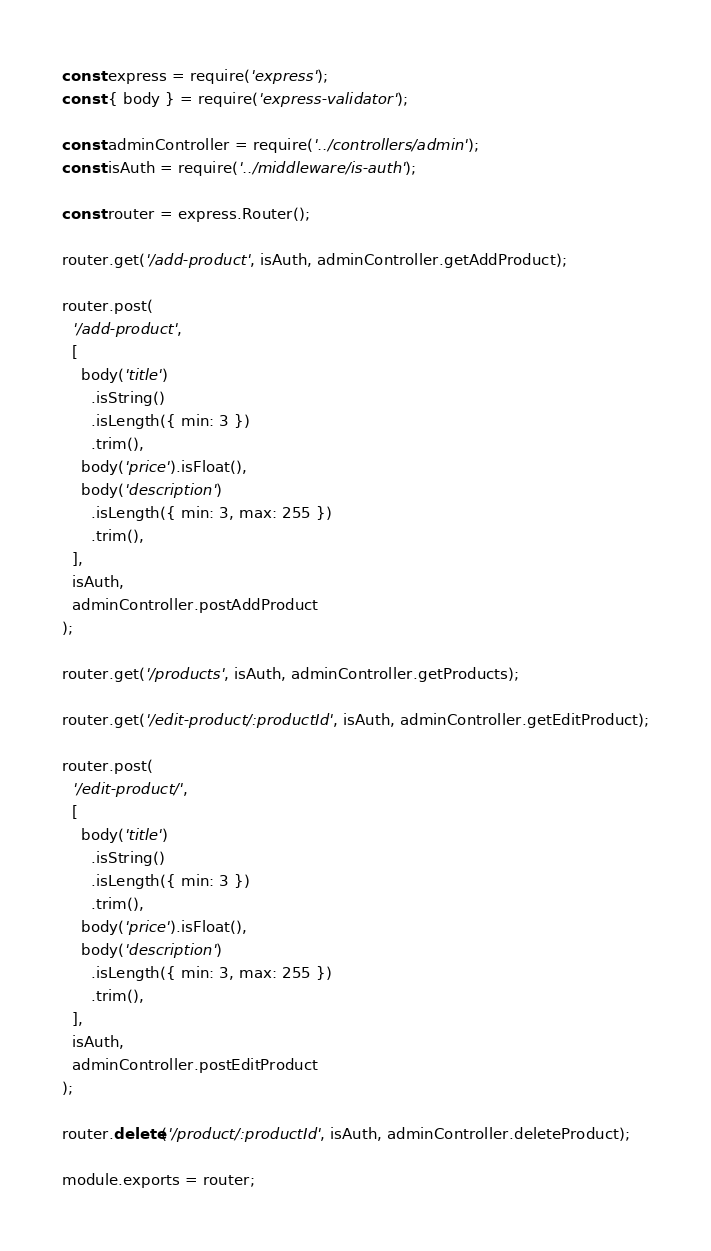Convert code to text. <code><loc_0><loc_0><loc_500><loc_500><_JavaScript_>const express = require('express');
const { body } = require('express-validator');

const adminController = require('../controllers/admin');
const isAuth = require('../middleware/is-auth');

const router = express.Router();

router.get('/add-product', isAuth, adminController.getAddProduct);

router.post(
  '/add-product',
  [
    body('title')
      .isString()
      .isLength({ min: 3 })
      .trim(),
    body('price').isFloat(),
    body('description')
      .isLength({ min: 3, max: 255 })
      .trim(),
  ],
  isAuth,
  adminController.postAddProduct
);

router.get('/products', isAuth, adminController.getProducts);

router.get('/edit-product/:productId', isAuth, adminController.getEditProduct);

router.post(
  '/edit-product/',
  [
    body('title')
      .isString()
      .isLength({ min: 3 })
      .trim(),
    body('price').isFloat(),
    body('description')
      .isLength({ min: 3, max: 255 })
      .trim(),
  ],
  isAuth,
  adminController.postEditProduct
);

router.delete('/product/:productId', isAuth, adminController.deleteProduct);

module.exports = router;
</code> 